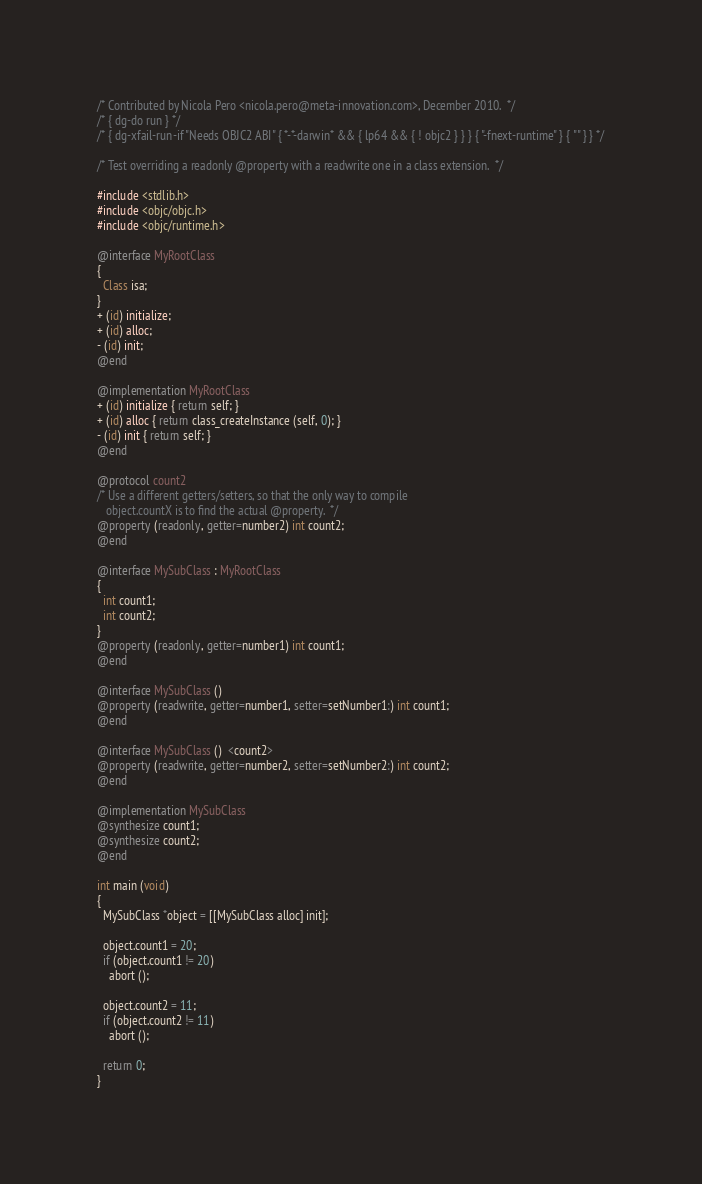<code> <loc_0><loc_0><loc_500><loc_500><_ObjectiveC_>/* Contributed by Nicola Pero <nicola.pero@meta-innovation.com>, December 2010.  */
/* { dg-do run } */
/* { dg-xfail-run-if "Needs OBJC2 ABI" { *-*-darwin* && { lp64 && { ! objc2 } } } { "-fnext-runtime" } { "" } } */

/* Test overriding a readonly @property with a readwrite one in a class extension.  */

#include <stdlib.h>
#include <objc/objc.h>
#include <objc/runtime.h>

@interface MyRootClass
{
  Class isa;
}
+ (id) initialize;
+ (id) alloc;
- (id) init;
@end

@implementation MyRootClass
+ (id) initialize { return self; }
+ (id) alloc { return class_createInstance (self, 0); }
- (id) init { return self; }
@end

@protocol count2
/* Use a different getters/setters, so that the only way to compile
   object.countX is to find the actual @property.  */
@property (readonly, getter=number2) int count2;
@end

@interface MySubClass : MyRootClass
{
  int count1;
  int count2;
}
@property (readonly, getter=number1) int count1;
@end

@interface MySubClass ()
@property (readwrite, getter=number1, setter=setNumber1:) int count1;
@end

@interface MySubClass ()  <count2>
@property (readwrite, getter=number2, setter=setNumber2:) int count2;
@end

@implementation MySubClass
@synthesize count1;
@synthesize count2;
@end

int main (void)
{
  MySubClass *object = [[MySubClass alloc] init];

  object.count1 = 20;
  if (object.count1 != 20)
    abort ();

  object.count2 = 11;
  if (object.count2 != 11)
    abort ();

  return 0;
}
</code> 